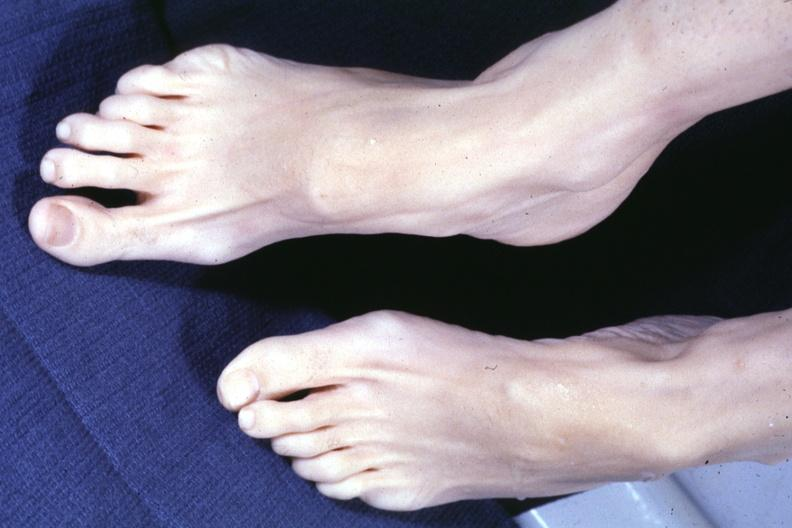does metastatic carcinoma oat cell show both feet with aortic dissection and mitral prolapse extremities which suggest marfans?
Answer the question using a single word or phrase. No 